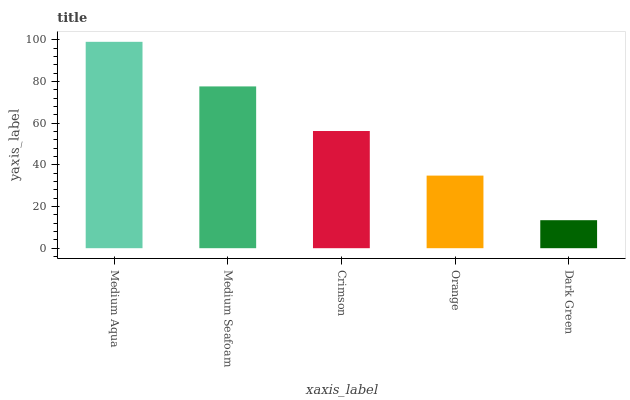Is Dark Green the minimum?
Answer yes or no. Yes. Is Medium Aqua the maximum?
Answer yes or no. Yes. Is Medium Seafoam the minimum?
Answer yes or no. No. Is Medium Seafoam the maximum?
Answer yes or no. No. Is Medium Aqua greater than Medium Seafoam?
Answer yes or no. Yes. Is Medium Seafoam less than Medium Aqua?
Answer yes or no. Yes. Is Medium Seafoam greater than Medium Aqua?
Answer yes or no. No. Is Medium Aqua less than Medium Seafoam?
Answer yes or no. No. Is Crimson the high median?
Answer yes or no. Yes. Is Crimson the low median?
Answer yes or no. Yes. Is Medium Seafoam the high median?
Answer yes or no. No. Is Dark Green the low median?
Answer yes or no. No. 